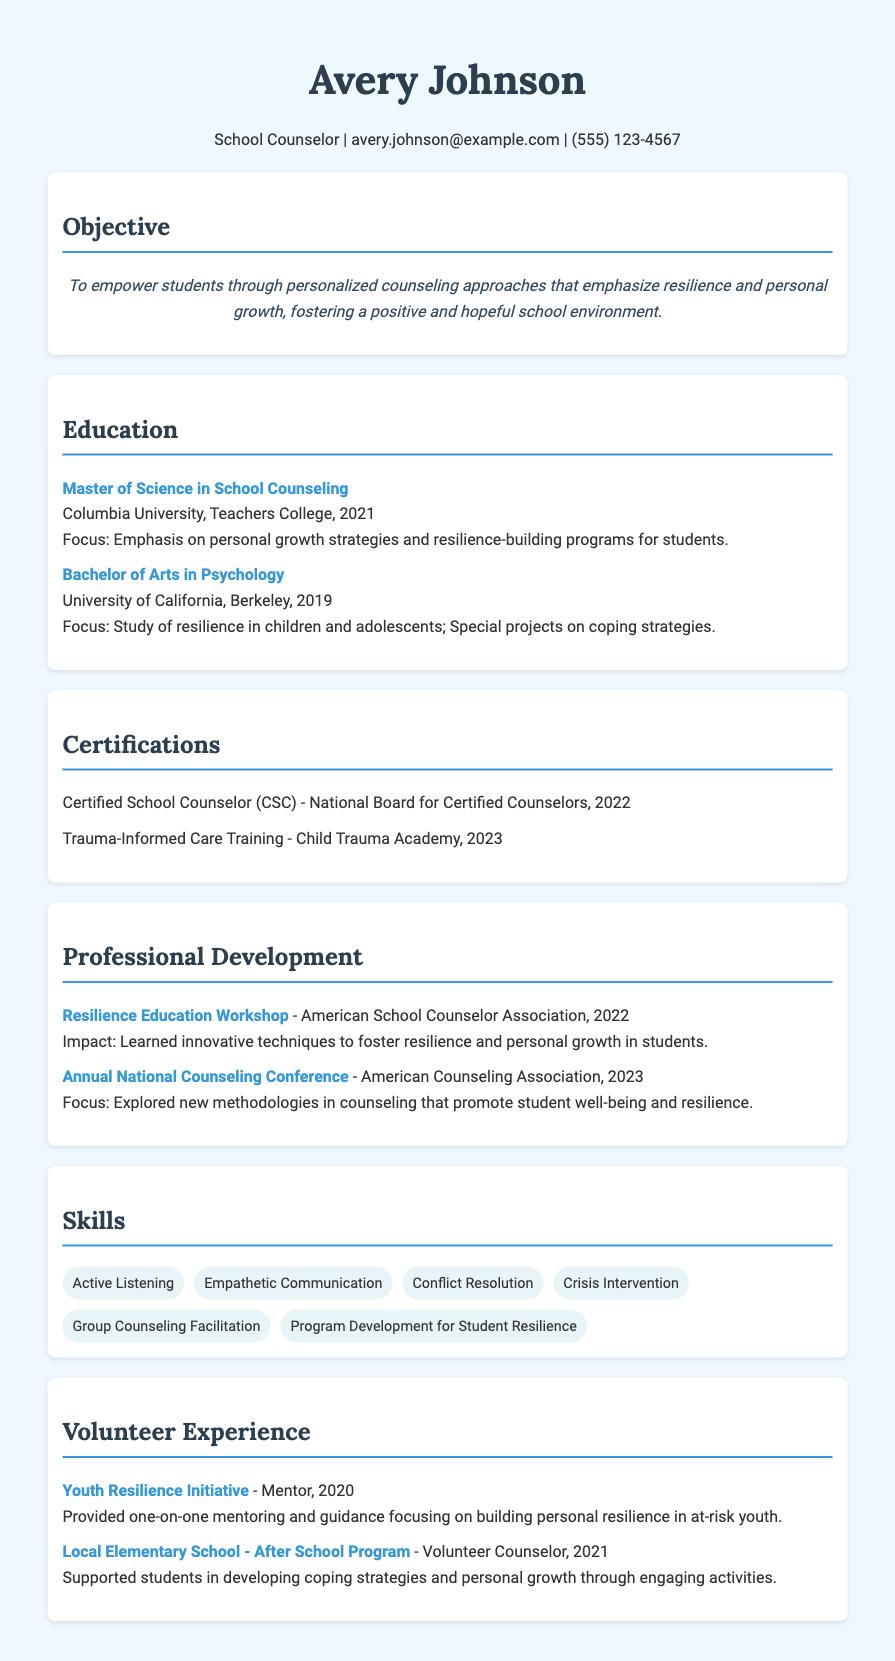What is Avery Johnson's highest degree? The highest degree listed in the document is a Master of Science in School Counseling from Columbia University, Teachers College.
Answer: Master of Science in School Counseling In what year did Avery Johnson obtain their Bachelor's degree? The Bachelor's degree was obtained from the University of California, Berkeley in 2019.
Answer: 2019 What is the focus of the Master's program? The focus of the Master of Science in School Counseling program is on personal growth strategies and resilience-building programs for students.
Answer: Personal growth strategies and resilience-building programs for students Which certification did Avery receive in 2022? The certification received in 2022 is the Certified School Counselor (CSC) from the National Board for Certified Counselors.
Answer: Certified School Counselor (CSC) What was the name of the workshop that Avery attended in 2022? The workshop attended in 2022 was the Resilience Education Workshop organized by the American School Counselor Association.
Answer: Resilience Education Workshop What is one skill listed in the CV related to supporting students? One of the skills listed is "Program Development for Student Resilience," which is focused on helping students build resilience.
Answer: Program Development for Student Resilience How many years of experience does Avery have as a counselor by 2023? Counting from the graduation date of 2021 and considering the volunteer experiences listed, as well as certifications, Avery has about 2 years of experience as a counselor by 2023.
Answer: 2 years In which initiative did Avery serve as a mentor? Avery served as a mentor in the "Youth Resilience Initiative" where they focused on building personal resilience.
Answer: Youth Resilience Initiative 